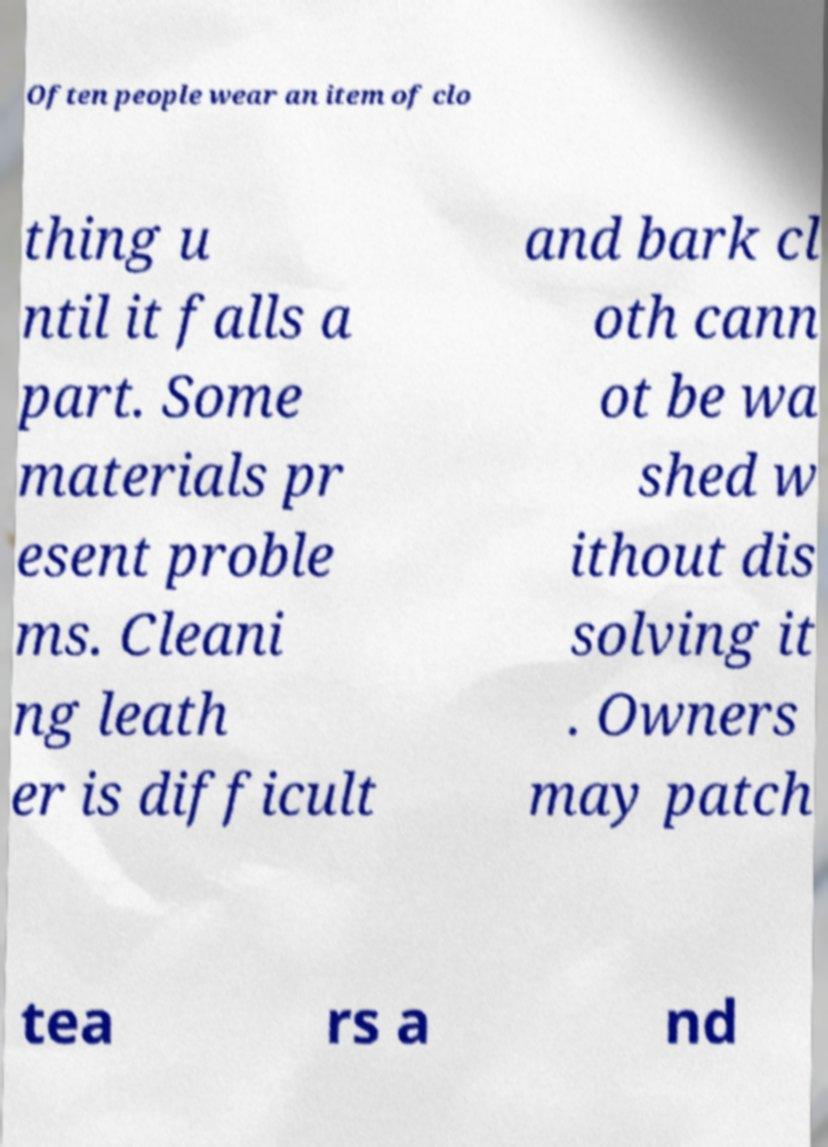Please identify and transcribe the text found in this image. Often people wear an item of clo thing u ntil it falls a part. Some materials pr esent proble ms. Cleani ng leath er is difficult and bark cl oth cann ot be wa shed w ithout dis solving it . Owners may patch tea rs a nd 